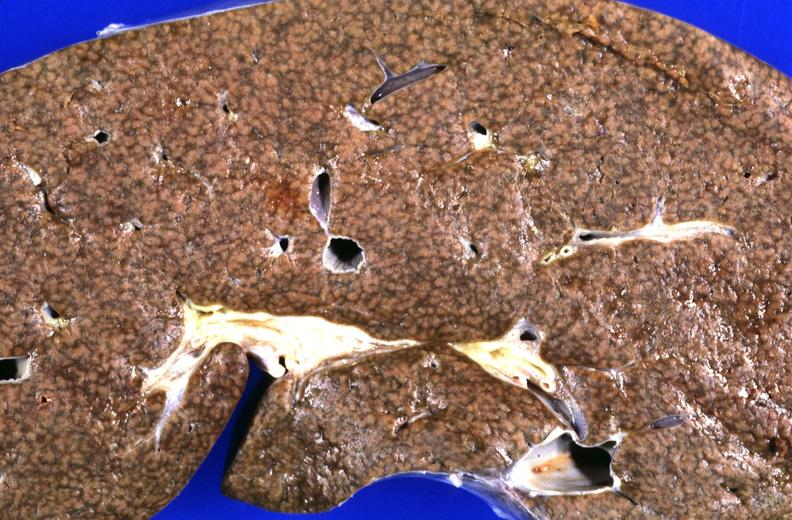what is present?
Answer the question using a single word or phrase. Hepatobiliary 